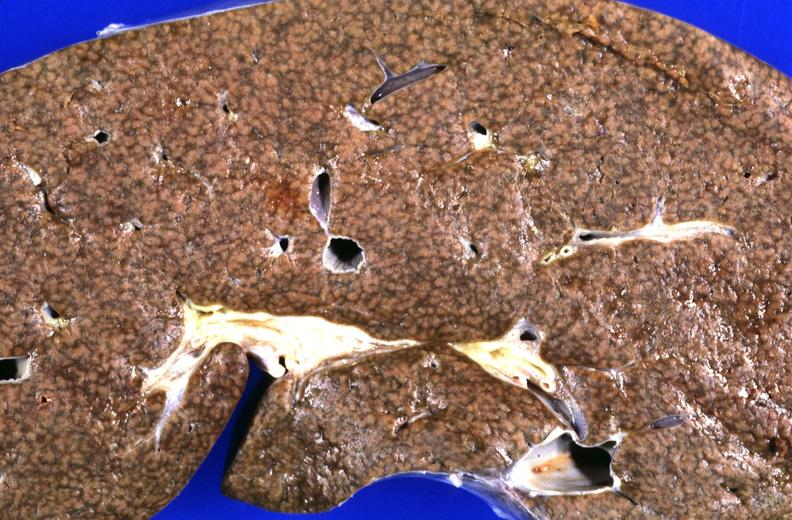what is present?
Answer the question using a single word or phrase. Hepatobiliary 